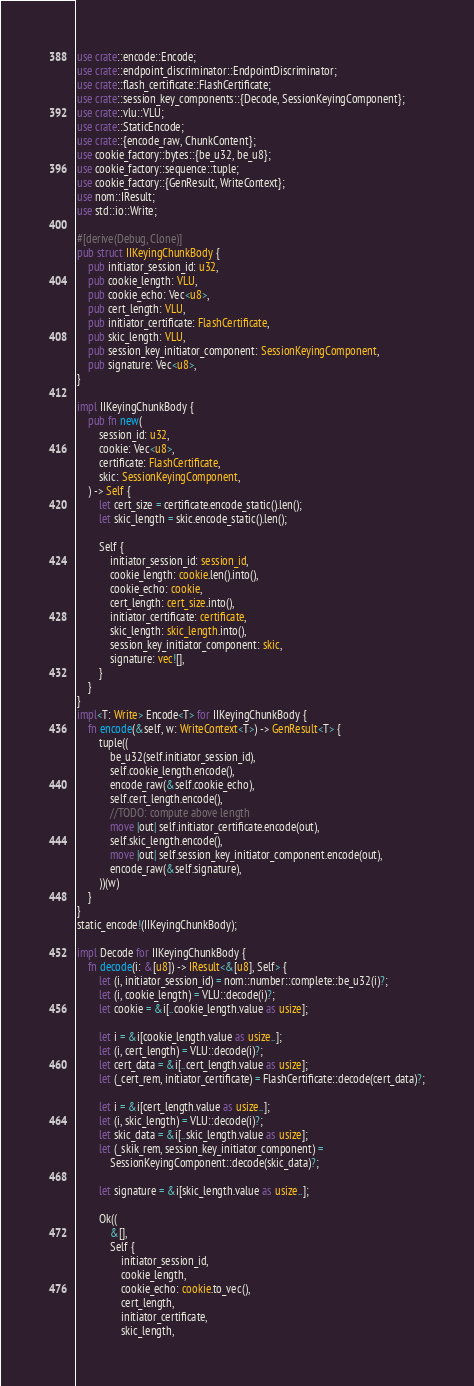<code> <loc_0><loc_0><loc_500><loc_500><_Rust_>use crate::encode::Encode;
use crate::endpoint_discriminator::EndpointDiscriminator;
use crate::flash_certificate::FlashCertificate;
use crate::session_key_components::{Decode, SessionKeyingComponent};
use crate::vlu::VLU;
use crate::StaticEncode;
use crate::{encode_raw, ChunkContent};
use cookie_factory::bytes::{be_u32, be_u8};
use cookie_factory::sequence::tuple;
use cookie_factory::{GenResult, WriteContext};
use nom::IResult;
use std::io::Write;

#[derive(Debug, Clone)]
pub struct IIKeyingChunkBody {
    pub initiator_session_id: u32,
    pub cookie_length: VLU,
    pub cookie_echo: Vec<u8>,
    pub cert_length: VLU,
    pub initiator_certificate: FlashCertificate,
    pub skic_length: VLU,
    pub session_key_initiator_component: SessionKeyingComponent,
    pub signature: Vec<u8>,
}

impl IIKeyingChunkBody {
    pub fn new(
        session_id: u32,
        cookie: Vec<u8>,
        certificate: FlashCertificate,
        skic: SessionKeyingComponent,
    ) -> Self {
        let cert_size = certificate.encode_static().len();
        let skic_length = skic.encode_static().len();

        Self {
            initiator_session_id: session_id,
            cookie_length: cookie.len().into(),
            cookie_echo: cookie,
            cert_length: cert_size.into(),
            initiator_certificate: certificate,
            skic_length: skic_length.into(),
            session_key_initiator_component: skic,
            signature: vec![],
        }
    }
}
impl<T: Write> Encode<T> for IIKeyingChunkBody {
    fn encode(&self, w: WriteContext<T>) -> GenResult<T> {
        tuple((
            be_u32(self.initiator_session_id),
            self.cookie_length.encode(),
            encode_raw(&self.cookie_echo),
            self.cert_length.encode(),
            //TODO: compute above length
            move |out| self.initiator_certificate.encode(out),
            self.skic_length.encode(),
            move |out| self.session_key_initiator_component.encode(out),
            encode_raw(&self.signature),
        ))(w)
    }
}
static_encode!(IIKeyingChunkBody);

impl Decode for IIKeyingChunkBody {
    fn decode(i: &[u8]) -> IResult<&[u8], Self> {
        let (i, initiator_session_id) = nom::number::complete::be_u32(i)?;
        let (i, cookie_length) = VLU::decode(i)?;
        let cookie = &i[..cookie_length.value as usize];

        let i = &i[cookie_length.value as usize..];
        let (i, cert_length) = VLU::decode(i)?;
        let cert_data = &i[..cert_length.value as usize];
        let (_cert_rem, initiator_certificate) = FlashCertificate::decode(cert_data)?;

        let i = &i[cert_length.value as usize..];
        let (i, skic_length) = VLU::decode(i)?;
        let skic_data = &i[..skic_length.value as usize];
        let (_skik_rem, session_key_initiator_component) =
            SessionKeyingComponent::decode(skic_data)?;

        let signature = &i[skic_length.value as usize..];

        Ok((
            &[],
            Self {
                initiator_session_id,
                cookie_length,
                cookie_echo: cookie.to_vec(),
                cert_length,
                initiator_certificate,
                skic_length,</code> 